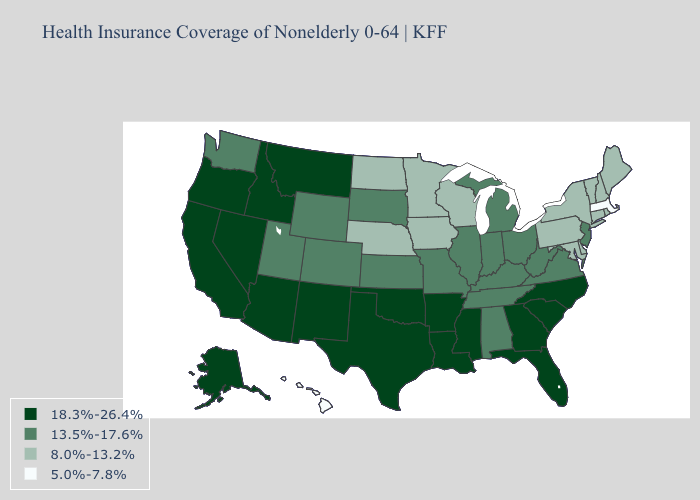Is the legend a continuous bar?
Keep it brief. No. Name the states that have a value in the range 13.5%-17.6%?
Answer briefly. Alabama, Colorado, Illinois, Indiana, Kansas, Kentucky, Michigan, Missouri, New Jersey, Ohio, South Dakota, Tennessee, Utah, Virginia, Washington, West Virginia, Wyoming. Does Texas have the lowest value in the South?
Be succinct. No. What is the value of Mississippi?
Write a very short answer. 18.3%-26.4%. Name the states that have a value in the range 18.3%-26.4%?
Quick response, please. Alaska, Arizona, Arkansas, California, Florida, Georgia, Idaho, Louisiana, Mississippi, Montana, Nevada, New Mexico, North Carolina, Oklahoma, Oregon, South Carolina, Texas. Name the states that have a value in the range 8.0%-13.2%?
Be succinct. Connecticut, Delaware, Iowa, Maine, Maryland, Minnesota, Nebraska, New Hampshire, New York, North Dakota, Pennsylvania, Rhode Island, Vermont, Wisconsin. What is the value of Indiana?
Concise answer only. 13.5%-17.6%. Name the states that have a value in the range 13.5%-17.6%?
Write a very short answer. Alabama, Colorado, Illinois, Indiana, Kansas, Kentucky, Michigan, Missouri, New Jersey, Ohio, South Dakota, Tennessee, Utah, Virginia, Washington, West Virginia, Wyoming. Name the states that have a value in the range 5.0%-7.8%?
Concise answer only. Hawaii, Massachusetts. Which states have the lowest value in the West?
Give a very brief answer. Hawaii. Does Oregon have the highest value in the West?
Write a very short answer. Yes. What is the lowest value in the South?
Write a very short answer. 8.0%-13.2%. What is the lowest value in states that border Rhode Island?
Concise answer only. 5.0%-7.8%. Name the states that have a value in the range 8.0%-13.2%?
Short answer required. Connecticut, Delaware, Iowa, Maine, Maryland, Minnesota, Nebraska, New Hampshire, New York, North Dakota, Pennsylvania, Rhode Island, Vermont, Wisconsin. Does the map have missing data?
Give a very brief answer. No. 